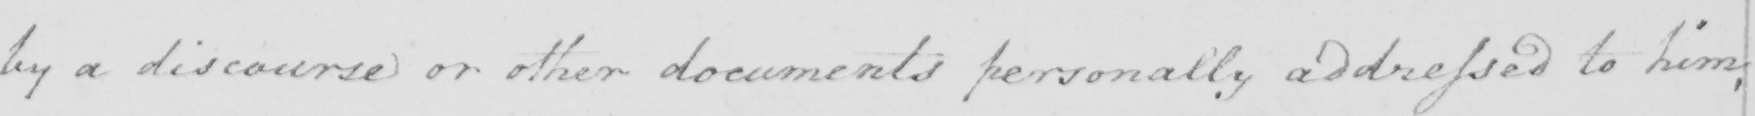Transcribe the text shown in this historical manuscript line. by a discourse or other documents personally addressed to him , 